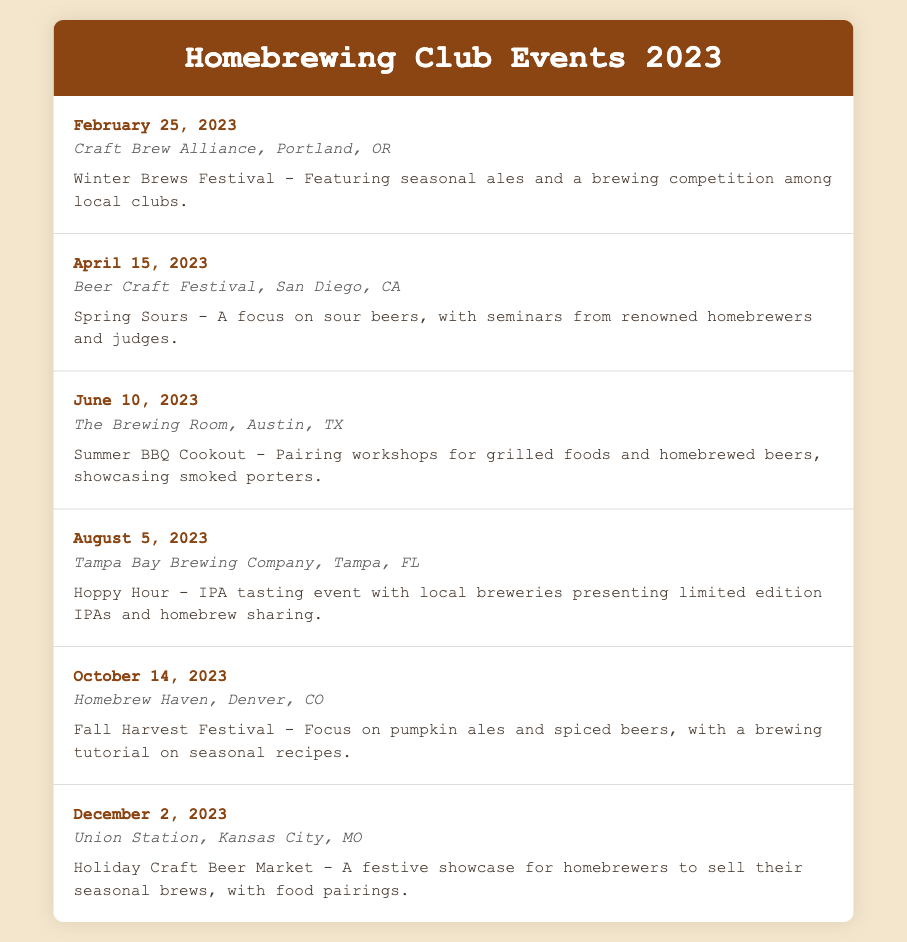what date is the Winter Brews Festival? The Winter Brews Festival is scheduled for February 25, 2023.
Answer: February 25, 2023 where is the Spring Sours event held? The Spring Sours event is held at Beer Craft Festival, San Diego, CA.
Answer: Beer Craft Festival, San Diego, CA which event focuses on seasonal ales? The event focusing on seasonal ales is the Fall Harvest Festival.
Answer: Fall Harvest Festival how many events are listed in total? There are six events listed in total in the 2023 event calendar.
Answer: 6 what highlight is associated with the Summer BBQ Cookout? The highlight associated with the Summer BBQ Cookout is pairing workshops for grilled foods and homebrewed beers, showcasing smoked porters.
Answer: Pairing workshops for grilled foods and homebrewed beers, showcasing smoked porters what is the location for the Holiday Craft Beer Market? The Holiday Craft Beer Market takes place at Union Station, Kansas City, MO.
Answer: Union Station, Kansas City, MO which event will cover brewing tutorials? The event that will cover brewing tutorials is the Fall Harvest Festival.
Answer: Fall Harvest Festival which event occurs in August? The event that occurs in August is Hoppy Hour.
Answer: Hoppy Hour 